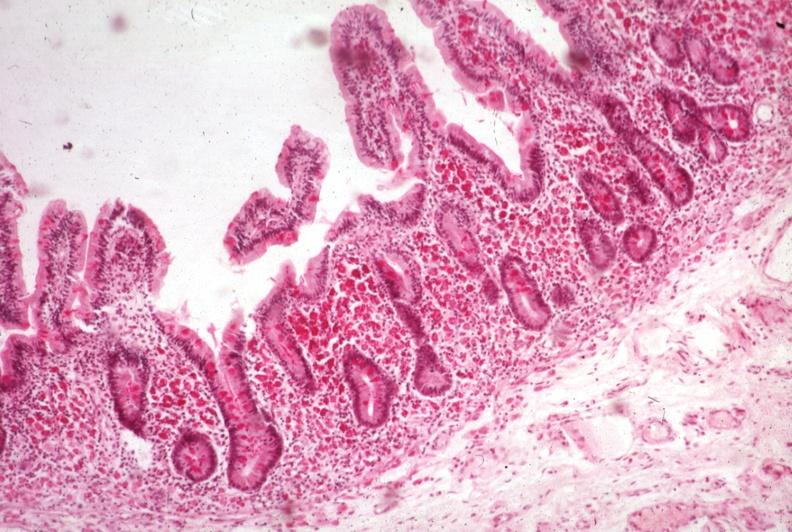what is present?
Answer the question using a single word or phrase. Gastrointestinal 